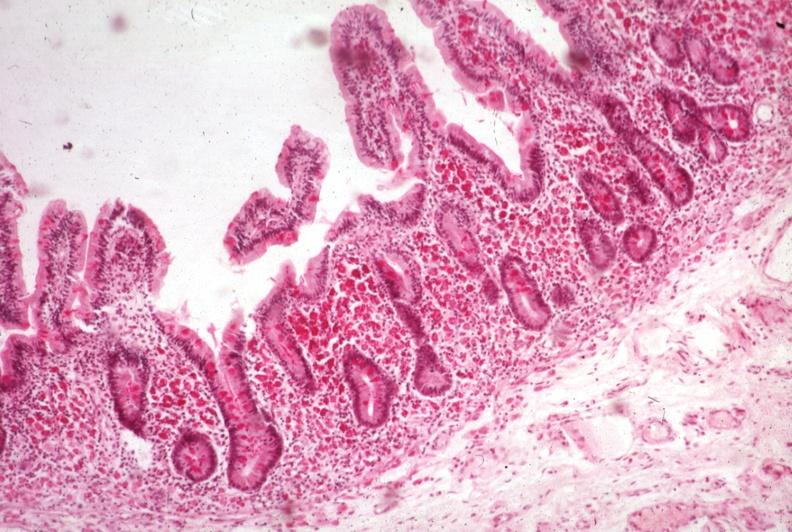what is present?
Answer the question using a single word or phrase. Gastrointestinal 